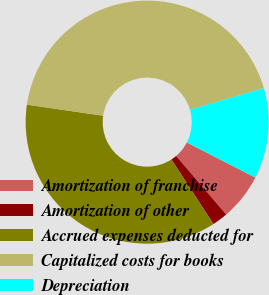Convert chart to OTSL. <chart><loc_0><loc_0><loc_500><loc_500><pie_chart><fcel>Amortization of franchise<fcel>Amortization of other<fcel>Accrued expenses deducted for<fcel>Capitalized costs for books<fcel>Depreciation<nl><fcel>6.2%<fcel>2.09%<fcel>36.47%<fcel>43.2%<fcel>12.05%<nl></chart> 